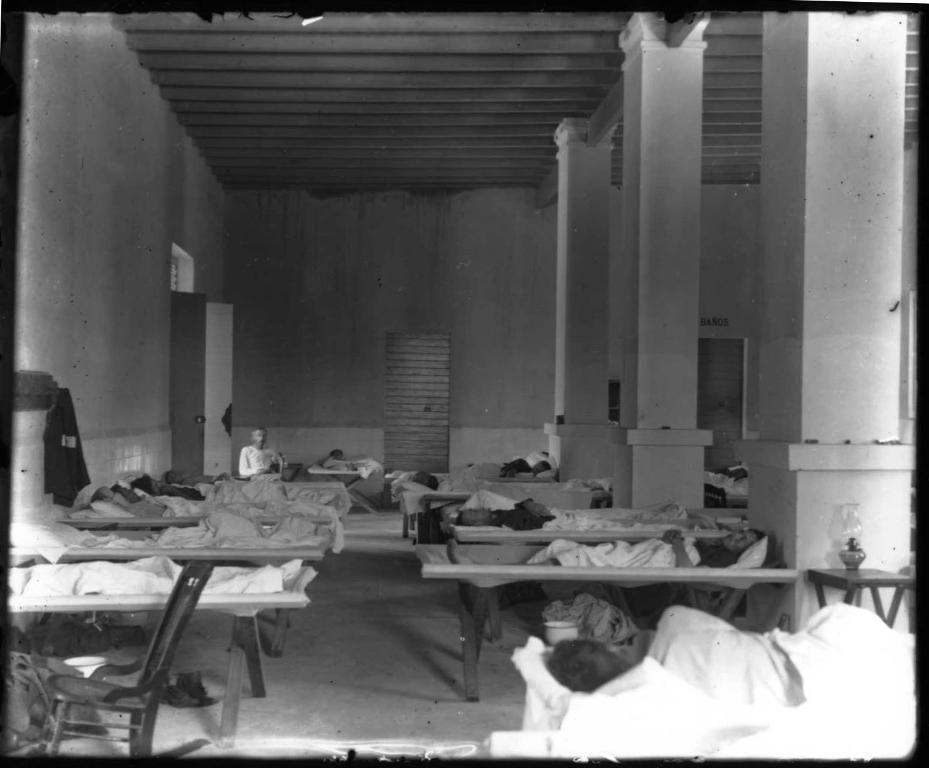What is the color scheme of the image? The image is black and white. What type of furniture can be seen in the image? There are beds in the image. Who or what is present in the image? There are persons in the image. What architectural features are visible in the image? There are pillars and doors in the image. What type of structure is depicted in the image? There is a wall in the image. Can you tell me how many quince trees are growing near the coast in the image? There are no quince trees or coast visible in the image; it features a black and white scene with beds, persons, pillars, doors, and a wall. 